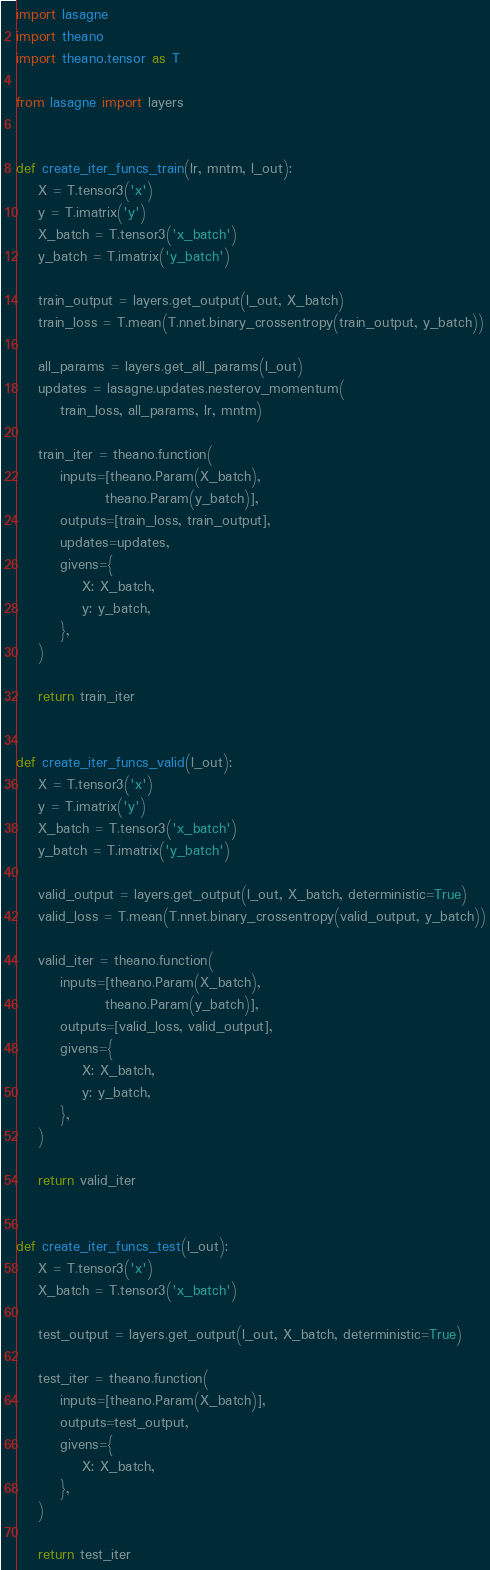<code> <loc_0><loc_0><loc_500><loc_500><_Python_>import lasagne
import theano
import theano.tensor as T

from lasagne import layers


def create_iter_funcs_train(lr, mntm, l_out):
    X = T.tensor3('x')
    y = T.imatrix('y')
    X_batch = T.tensor3('x_batch')
    y_batch = T.imatrix('y_batch')

    train_output = layers.get_output(l_out, X_batch)
    train_loss = T.mean(T.nnet.binary_crossentropy(train_output, y_batch))

    all_params = layers.get_all_params(l_out)
    updates = lasagne.updates.nesterov_momentum(
        train_loss, all_params, lr, mntm)

    train_iter = theano.function(
        inputs=[theano.Param(X_batch),
                theano.Param(y_batch)],
        outputs=[train_loss, train_output],
        updates=updates,
        givens={
            X: X_batch,
            y: y_batch,
        },
    )

    return train_iter


def create_iter_funcs_valid(l_out):
    X = T.tensor3('x')
    y = T.imatrix('y')
    X_batch = T.tensor3('x_batch')
    y_batch = T.imatrix('y_batch')

    valid_output = layers.get_output(l_out, X_batch, deterministic=True)
    valid_loss = T.mean(T.nnet.binary_crossentropy(valid_output, y_batch))

    valid_iter = theano.function(
        inputs=[theano.Param(X_batch),
                theano.Param(y_batch)],
        outputs=[valid_loss, valid_output],
        givens={
            X: X_batch,
            y: y_batch,
        },
    )

    return valid_iter


def create_iter_funcs_test(l_out):
    X = T.tensor3('x')
    X_batch = T.tensor3('x_batch')

    test_output = layers.get_output(l_out, X_batch, deterministic=True)

    test_iter = theano.function(
        inputs=[theano.Param(X_batch)],
        outputs=test_output,
        givens={
            X: X_batch,
        },
    )

    return test_iter
</code> 